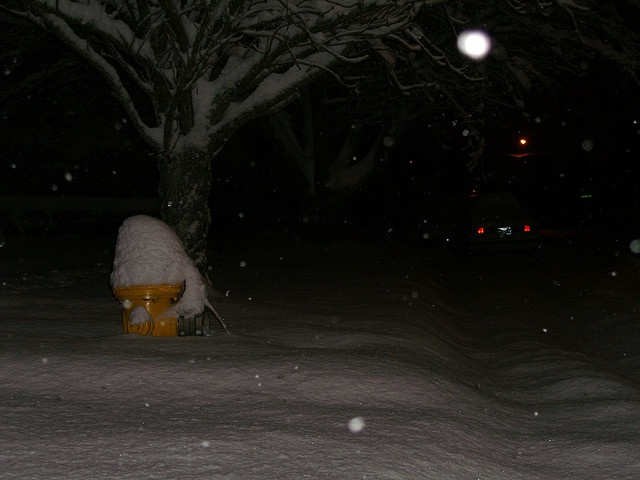Describe the objects in this image and their specific colors. I can see car in black, red, purple, and maroon tones and fire hydrant in black, maroon, and gray tones in this image. 